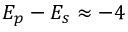Convert formula to latex. <formula><loc_0><loc_0><loc_500><loc_500>E _ { p } - E _ { s } \approx - 4</formula> 